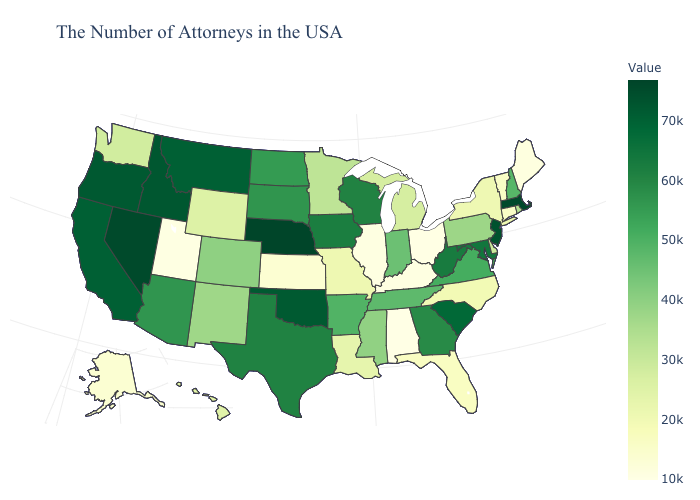Does Kentucky have a lower value than Tennessee?
Short answer required. Yes. Does New Hampshire have a higher value than Florida?
Short answer required. Yes. Among the states that border Iowa , does Illinois have the lowest value?
Keep it brief. Yes. Among the states that border New Mexico , does Arizona have the lowest value?
Give a very brief answer. No. Does Ohio have the lowest value in the MidWest?
Give a very brief answer. Yes. Which states have the lowest value in the Northeast?
Answer briefly. Maine. Among the states that border Vermont , does New York have the highest value?
Be succinct. No. 